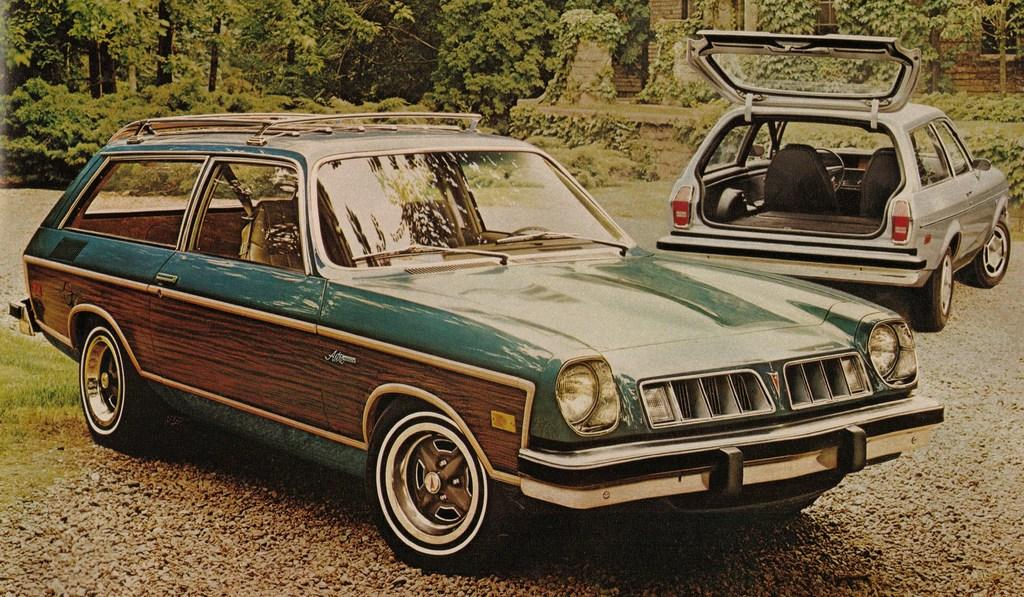How many cars are visible in the image? There are two cars in the image. What can be seen in the background of the image? There are plants and trees in the background of the image. Where is the house located in the image? The house is on the right side of the image. What color is the sock that the car is wearing in the image? There are no socks present in the image, as cars do not wear socks. 